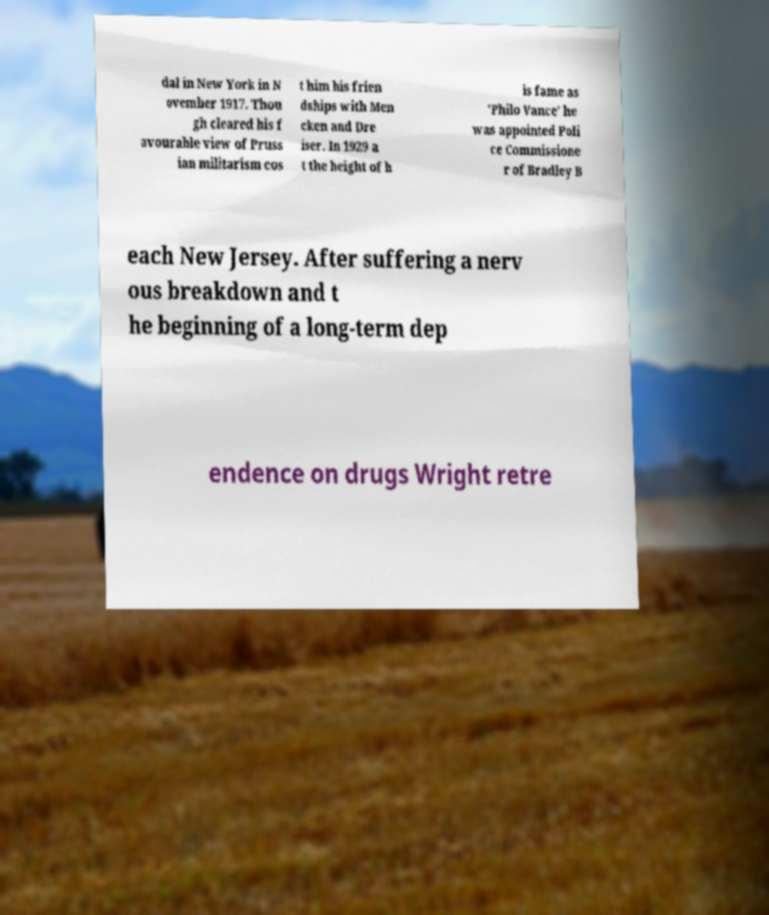Please read and relay the text visible in this image. What does it say? dal in New York in N ovember 1917. Thou gh cleared his f avourable view of Pruss ian militarism cos t him his frien dships with Men cken and Dre iser. In 1929 a t the height of h is fame as 'Philo Vance' he was appointed Poli ce Commissione r of Bradley B each New Jersey. After suffering a nerv ous breakdown and t he beginning of a long-term dep endence on drugs Wright retre 